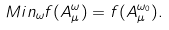Convert formula to latex. <formula><loc_0><loc_0><loc_500><loc_500>M i n _ { \omega } f ( A _ { \mu } ^ { \omega } ) = f ( A _ { \mu } ^ { \omega _ { 0 } } ) .</formula> 